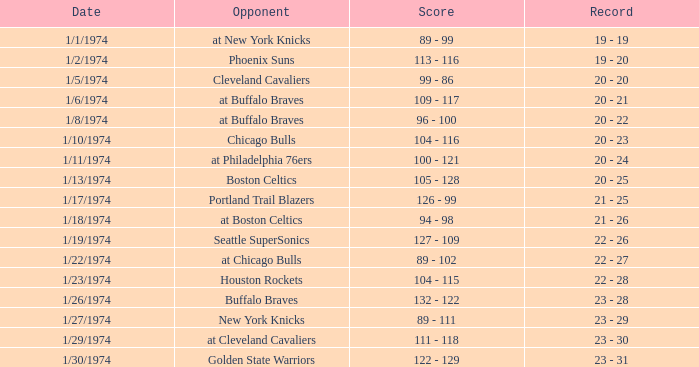What was the result on 1/10/1974? 104 - 116. 